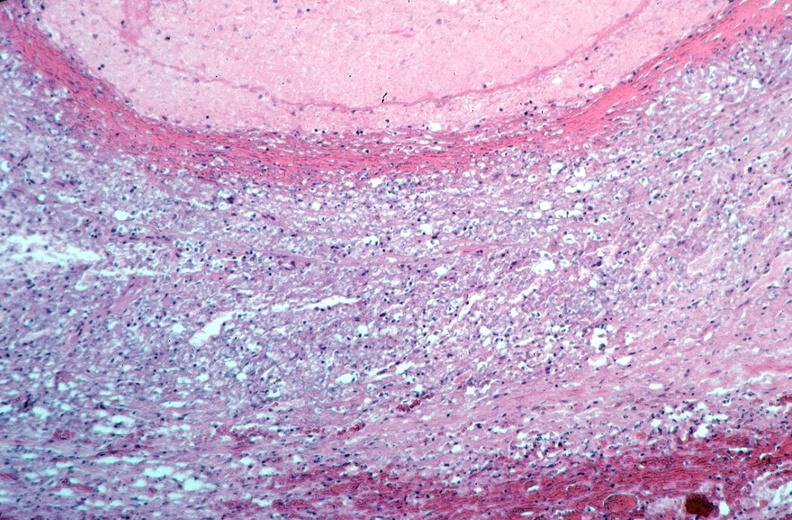s beckwith-wiedemann syndrome present?
Answer the question using a single word or phrase. No 